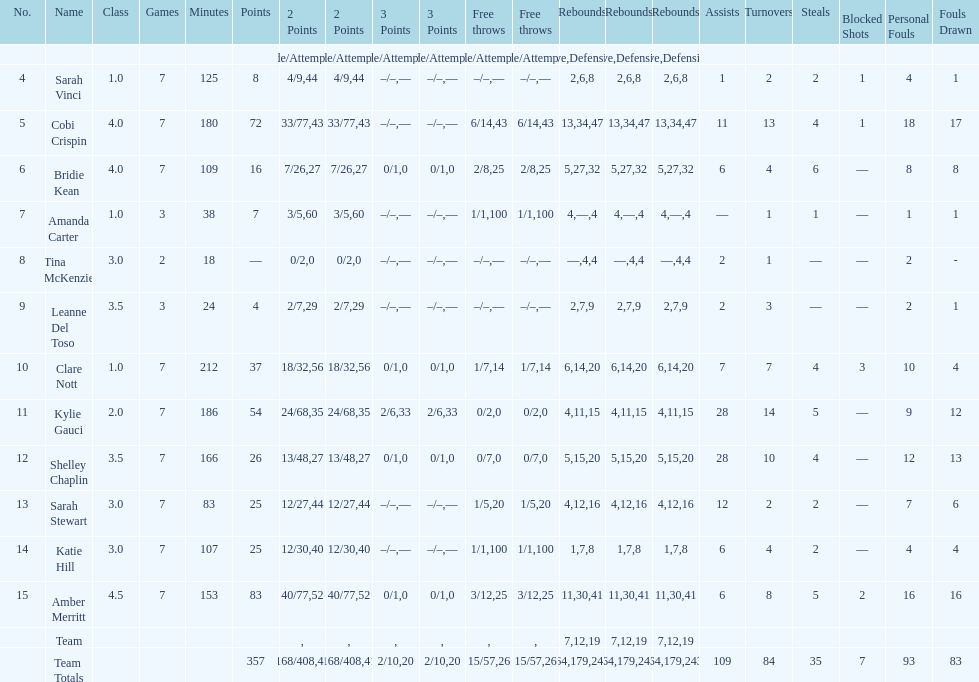Would you be able to parse every entry in this table? {'header': ['No.', 'Name', 'Class', 'Games', 'Minutes', 'Points', '2 Points', '2 Points', '3 Points', '3 Points', 'Free throws', 'Free throws', 'Rebounds', 'Rebounds', 'Rebounds', 'Assists', 'Turnovers', 'Steals', 'Blocked Shots', 'Personal Fouls', 'Fouls Drawn'], 'rows': [['', '', '', '', '', '', 'Made/Attempts', '%', 'Made/Attempts', '%', 'Made/Attempts', '%', 'Offensive', 'Defensive', 'Total', '', '', '', '', '', ''], ['4', 'Sarah Vinci', '1.0', '7', '125', '8', '4/9', '44', '–/–', '—', '–/–', '—', '2', '6', '8', '1', '2', '2', '1', '4', '1'], ['5', 'Cobi Crispin', '4.0', '7', '180', '72', '33/77', '43', '–/–', '—', '6/14', '43', '13', '34', '47', '11', '13', '4', '1', '18', '17'], ['6', 'Bridie Kean', '4.0', '7', '109', '16', '7/26', '27', '0/1', '0', '2/8', '25', '5', '27', '32', '6', '4', '6', '—', '8', '8'], ['7', 'Amanda Carter', '1.0', '3', '38', '7', '3/5', '60', '–/–', '—', '1/1', '100', '4', '—', '4', '—', '1', '1', '—', '1', '1'], ['8', 'Tina McKenzie', '3.0', '2', '18', '—', '0/2', '0', '–/–', '—', '–/–', '—', '—', '4', '4', '2', '1', '—', '—', '2', '-'], ['9', 'Leanne Del Toso', '3.5', '3', '24', '4', '2/7', '29', '–/–', '—', '–/–', '—', '2', '7', '9', '2', '3', '—', '—', '2', '1'], ['10', 'Clare Nott', '1.0', '7', '212', '37', '18/32', '56', '0/1', '0', '1/7', '14', '6', '14', '20', '7', '7', '4', '3', '10', '4'], ['11', 'Kylie Gauci', '2.0', '7', '186', '54', '24/68', '35', '2/6', '33', '0/2', '0', '4', '11', '15', '28', '14', '5', '—', '9', '12'], ['12', 'Shelley Chaplin', '3.5', '7', '166', '26', '13/48', '27', '0/1', '0', '0/7', '0', '5', '15', '20', '28', '10', '4', '—', '12', '13'], ['13', 'Sarah Stewart', '3.0', '7', '83', '25', '12/27', '44', '–/–', '—', '1/5', '20', '4', '12', '16', '12', '2', '2', '—', '7', '6'], ['14', 'Katie Hill', '3.0', '7', '107', '25', '12/30', '40', '–/–', '—', '1/1', '100', '1', '7', '8', '6', '4', '2', '—', '4', '4'], ['15', 'Amber Merritt', '4.5', '7', '153', '83', '40/77', '52', '0/1', '0', '3/12', '25', '11', '30', '41', '6', '8', '5', '2', '16', '16'], ['', 'Team', '', '', '', '', '', '', '', '', '', '', '7', '12', '19', '', '', '', '', '', ''], ['', 'Team Totals', '', '', '', '357', '168/408', '41', '2/10', '20', '15/57', '26', '64', '179', '243', '109', '84', '35', '7', '93', '83']]} What is the gap in points between the player with the highest score and the player with the lowest score? 83. 